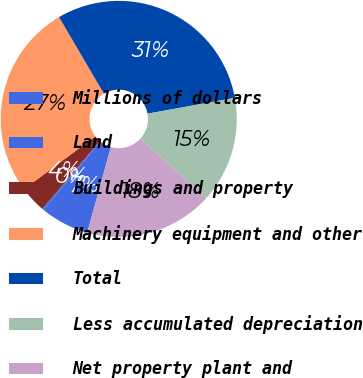Convert chart. <chart><loc_0><loc_0><loc_500><loc_500><pie_chart><fcel>Millions of dollars<fcel>Land<fcel>Buildings and property<fcel>Machinery equipment and other<fcel>Total<fcel>Less accumulated depreciation<fcel>Net property plant and<nl><fcel>6.67%<fcel>0.24%<fcel>3.64%<fcel>26.71%<fcel>30.59%<fcel>14.56%<fcel>17.59%<nl></chart> 